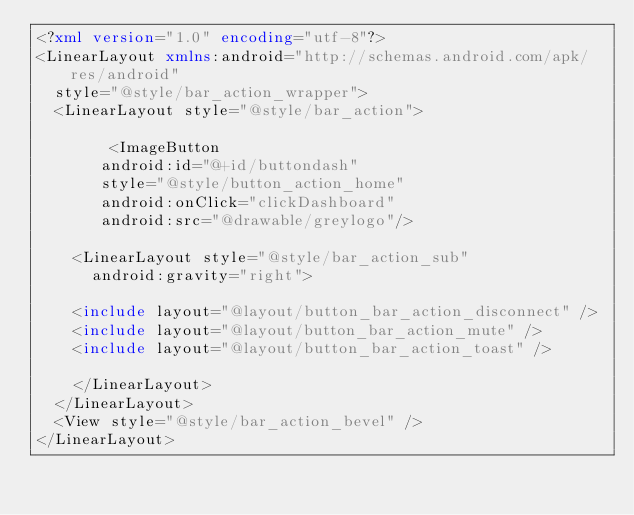Convert code to text. <code><loc_0><loc_0><loc_500><loc_500><_XML_><?xml version="1.0" encoding="utf-8"?>
<LinearLayout xmlns:android="http://schemas.android.com/apk/res/android"
	style="@style/bar_action_wrapper">
	<LinearLayout style="@style/bar_action">

        <ImageButton 
	     android:id="@+id/buttondash"
	     style="@style/button_action_home"
	     android:onClick="clickDashboard"
	     android:src="@drawable/greylogo"/>

		<LinearLayout style="@style/bar_action_sub"
			android:gravity="right">

		<include layout="@layout/button_bar_action_disconnect" />
		<include layout="@layout/button_bar_action_mute" />
		<include layout="@layout/button_bar_action_toast" />
		
		</LinearLayout>
	</LinearLayout>
	<View style="@style/bar_action_bevel" />
</LinearLayout></code> 